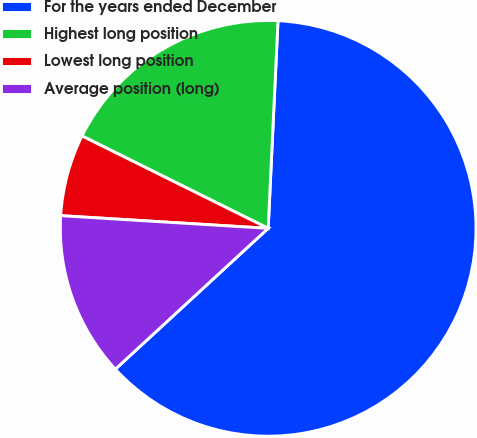<chart> <loc_0><loc_0><loc_500><loc_500><pie_chart><fcel>For the years ended December<fcel>Highest long position<fcel>Lowest long position<fcel>Average position (long)<nl><fcel>62.4%<fcel>18.42%<fcel>6.36%<fcel>12.82%<nl></chart> 